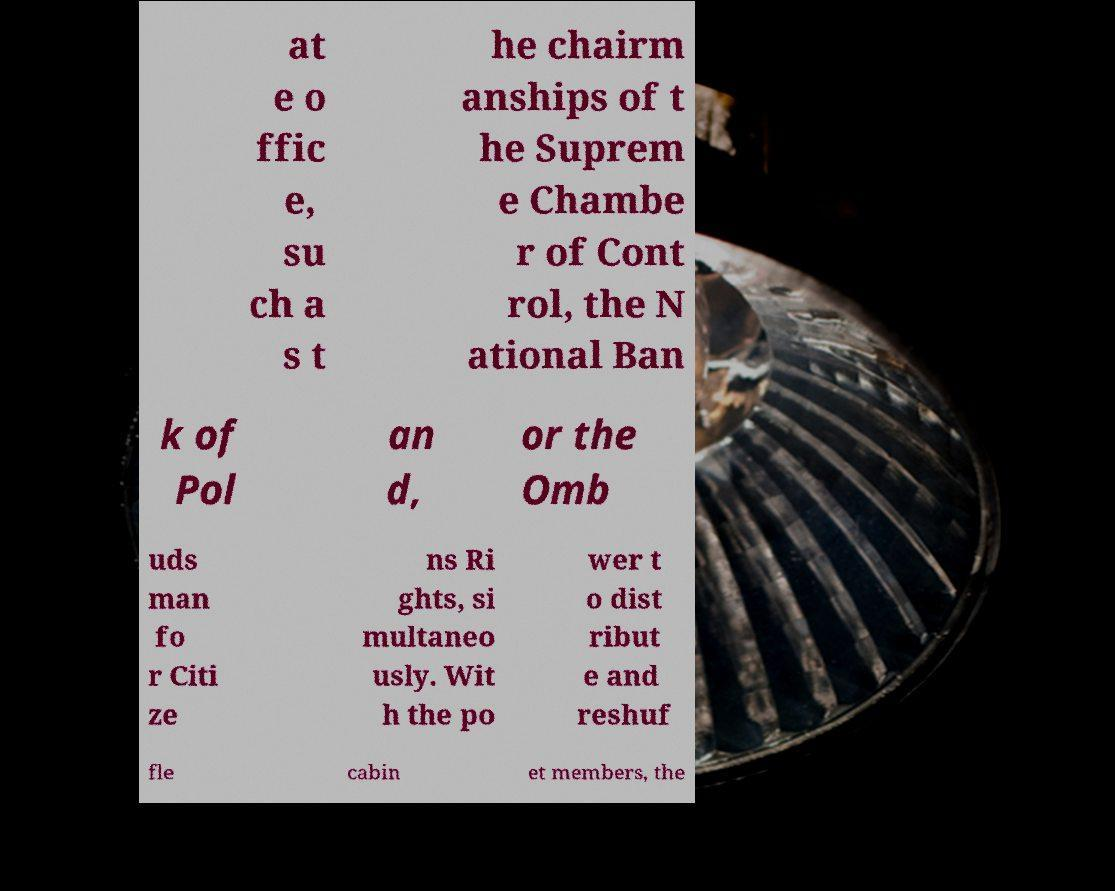Could you extract and type out the text from this image? at e o ffic e, su ch a s t he chairm anships of t he Suprem e Chambe r of Cont rol, the N ational Ban k of Pol an d, or the Omb uds man fo r Citi ze ns Ri ghts, si multaneo usly. Wit h the po wer t o dist ribut e and reshuf fle cabin et members, the 